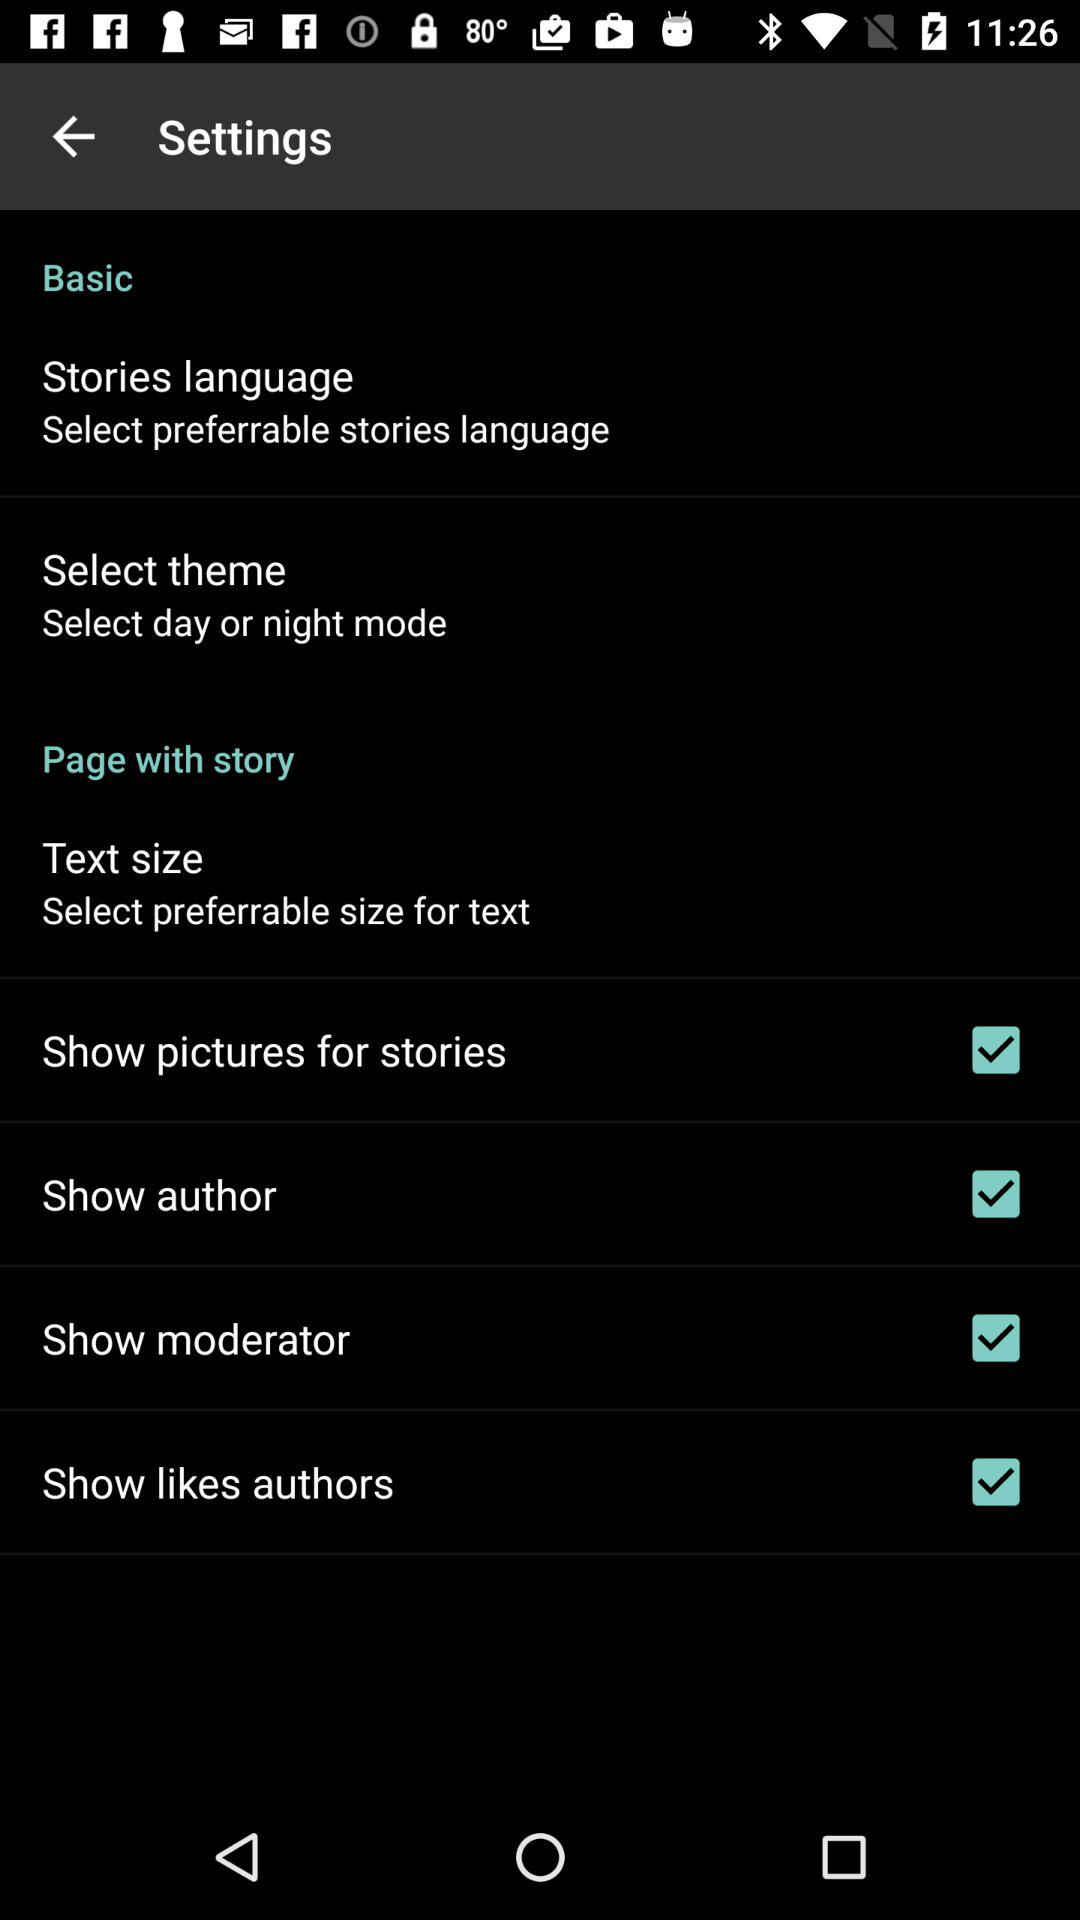What is the status of the "Show likes authors"? The status is "on". 